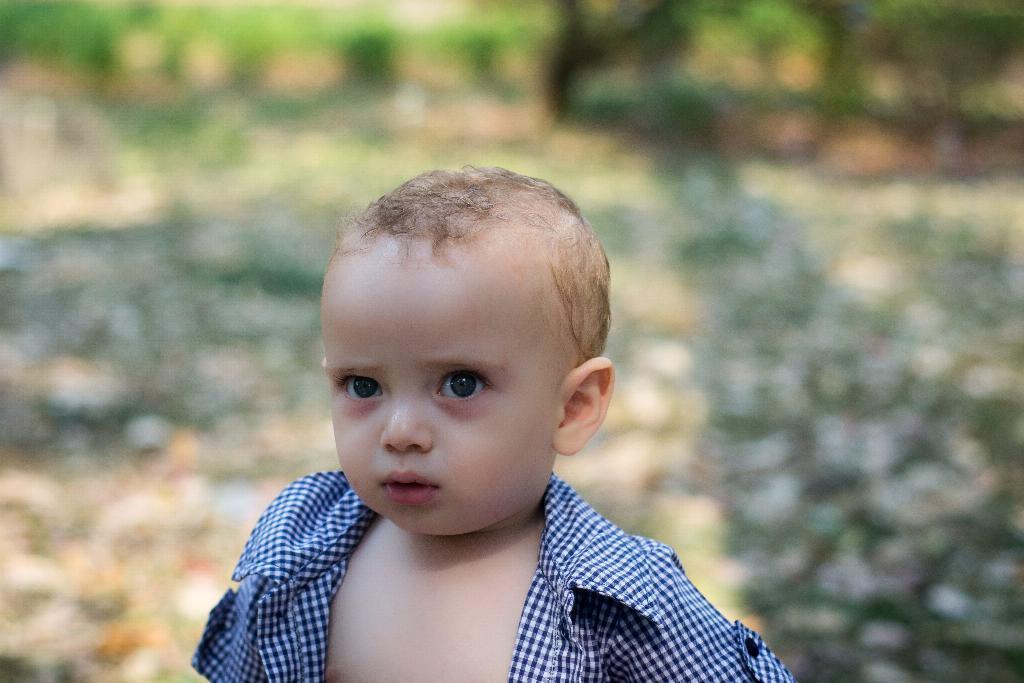How would you summarize this image in a sentence or two? There is a small boy in the center of the image and the background is blurry. 